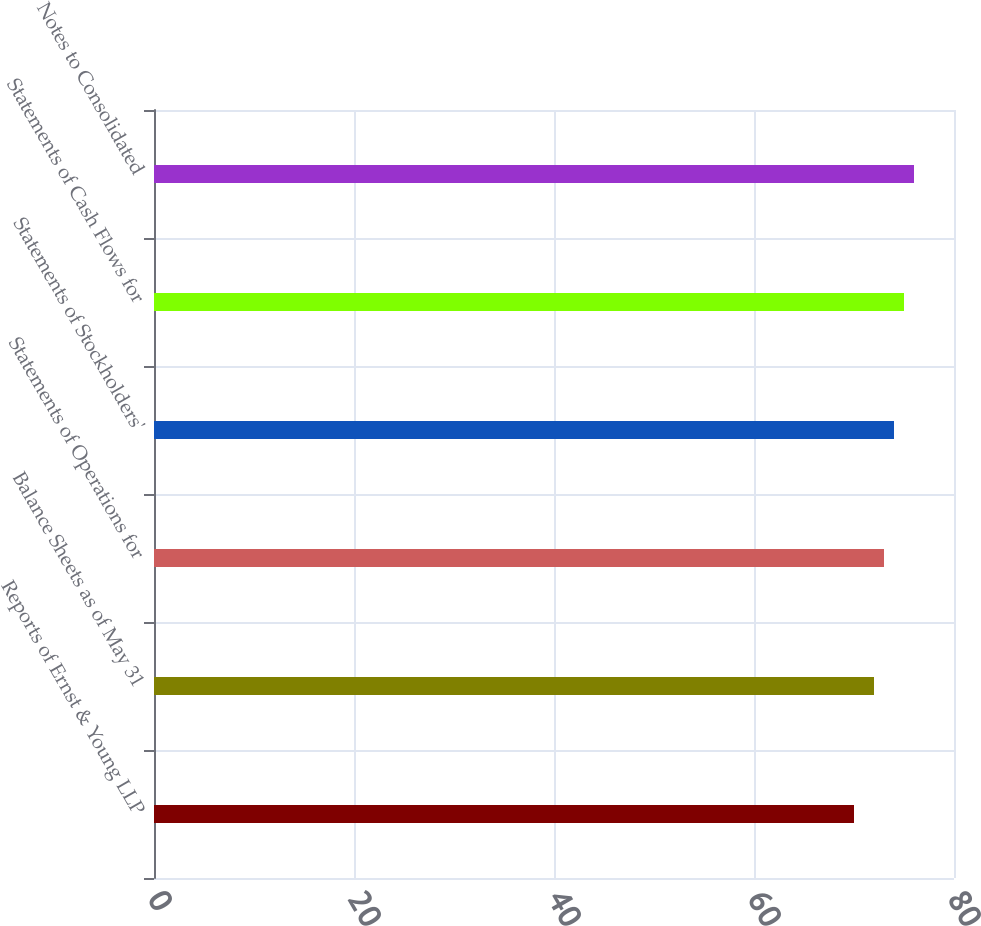Convert chart to OTSL. <chart><loc_0><loc_0><loc_500><loc_500><bar_chart><fcel>Reports of Ernst & Young LLP<fcel>Balance Sheets as of May 31<fcel>Statements of Operations for<fcel>Statements of Stockholders'<fcel>Statements of Cash Flows for<fcel>Notes to Consolidated<nl><fcel>70<fcel>72<fcel>73<fcel>74<fcel>75<fcel>76<nl></chart> 